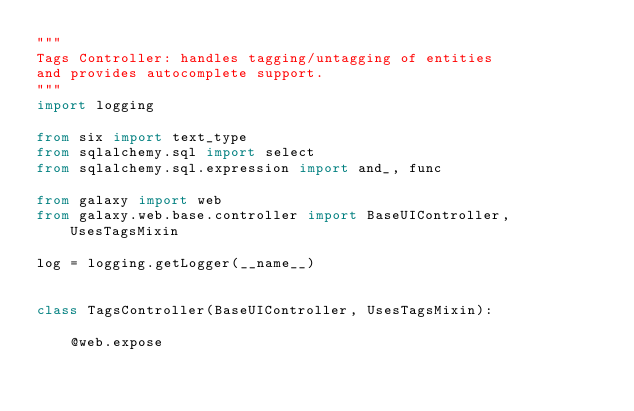<code> <loc_0><loc_0><loc_500><loc_500><_Python_>"""
Tags Controller: handles tagging/untagging of entities
and provides autocomplete support.
"""
import logging

from six import text_type
from sqlalchemy.sql import select
from sqlalchemy.sql.expression import and_, func

from galaxy import web
from galaxy.web.base.controller import BaseUIController, UsesTagsMixin

log = logging.getLogger(__name__)


class TagsController(BaseUIController, UsesTagsMixin):

    @web.expose</code> 